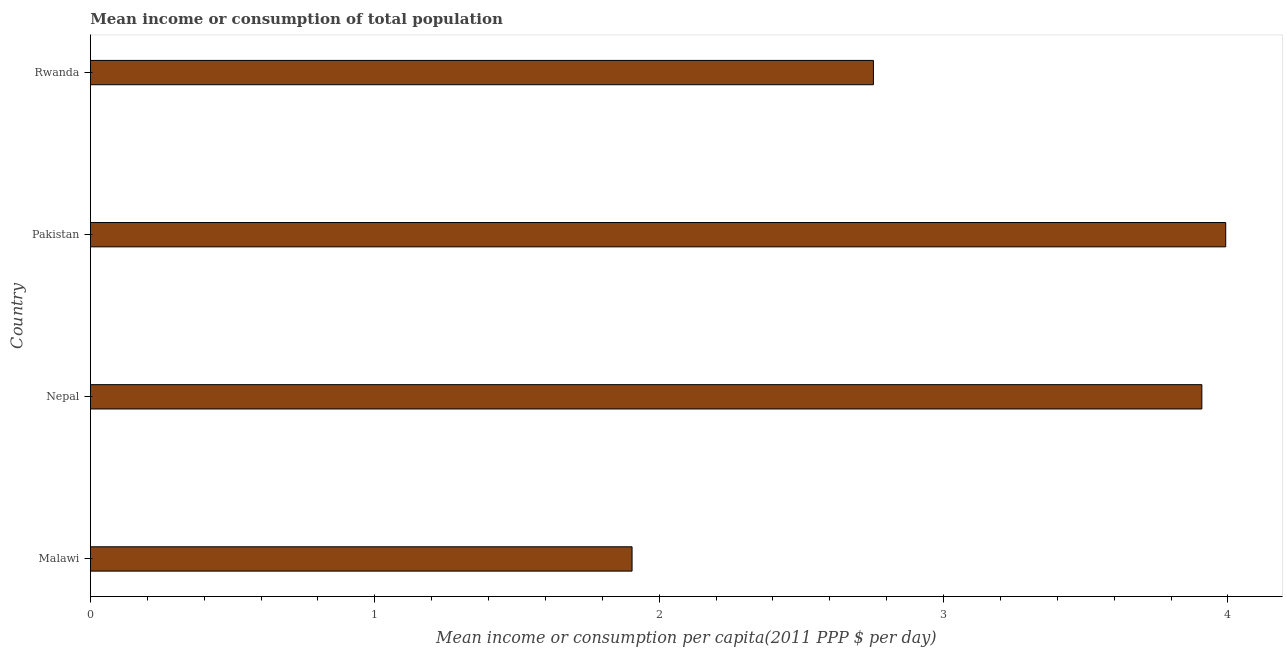Does the graph contain any zero values?
Give a very brief answer. No. What is the title of the graph?
Offer a terse response. Mean income or consumption of total population. What is the label or title of the X-axis?
Ensure brevity in your answer.  Mean income or consumption per capita(2011 PPP $ per day). What is the mean income or consumption in Rwanda?
Offer a very short reply. 2.75. Across all countries, what is the maximum mean income or consumption?
Give a very brief answer. 3.99. Across all countries, what is the minimum mean income or consumption?
Offer a very short reply. 1.9. In which country was the mean income or consumption maximum?
Your answer should be very brief. Pakistan. In which country was the mean income or consumption minimum?
Your answer should be compact. Malawi. What is the sum of the mean income or consumption?
Your response must be concise. 12.56. What is the difference between the mean income or consumption in Malawi and Nepal?
Provide a succinct answer. -2. What is the average mean income or consumption per country?
Offer a terse response. 3.14. What is the median mean income or consumption?
Offer a very short reply. 3.33. What is the ratio of the mean income or consumption in Nepal to that in Rwanda?
Keep it short and to the point. 1.42. What is the difference between the highest and the second highest mean income or consumption?
Provide a short and direct response. 0.08. Is the sum of the mean income or consumption in Nepal and Rwanda greater than the maximum mean income or consumption across all countries?
Your response must be concise. Yes. What is the difference between the highest and the lowest mean income or consumption?
Keep it short and to the point. 2.09. In how many countries, is the mean income or consumption greater than the average mean income or consumption taken over all countries?
Your answer should be compact. 2. Are all the bars in the graph horizontal?
Give a very brief answer. Yes. What is the difference between two consecutive major ticks on the X-axis?
Keep it short and to the point. 1. Are the values on the major ticks of X-axis written in scientific E-notation?
Ensure brevity in your answer.  No. What is the Mean income or consumption per capita(2011 PPP $ per day) in Malawi?
Your response must be concise. 1.9. What is the Mean income or consumption per capita(2011 PPP $ per day) of Nepal?
Provide a short and direct response. 3.91. What is the Mean income or consumption per capita(2011 PPP $ per day) in Pakistan?
Provide a succinct answer. 3.99. What is the Mean income or consumption per capita(2011 PPP $ per day) of Rwanda?
Your answer should be very brief. 2.75. What is the difference between the Mean income or consumption per capita(2011 PPP $ per day) in Malawi and Nepal?
Your response must be concise. -2. What is the difference between the Mean income or consumption per capita(2011 PPP $ per day) in Malawi and Pakistan?
Give a very brief answer. -2.09. What is the difference between the Mean income or consumption per capita(2011 PPP $ per day) in Malawi and Rwanda?
Offer a terse response. -0.85. What is the difference between the Mean income or consumption per capita(2011 PPP $ per day) in Nepal and Pakistan?
Your response must be concise. -0.08. What is the difference between the Mean income or consumption per capita(2011 PPP $ per day) in Nepal and Rwanda?
Make the answer very short. 1.15. What is the difference between the Mean income or consumption per capita(2011 PPP $ per day) in Pakistan and Rwanda?
Offer a terse response. 1.24. What is the ratio of the Mean income or consumption per capita(2011 PPP $ per day) in Malawi to that in Nepal?
Your answer should be compact. 0.49. What is the ratio of the Mean income or consumption per capita(2011 PPP $ per day) in Malawi to that in Pakistan?
Make the answer very short. 0.48. What is the ratio of the Mean income or consumption per capita(2011 PPP $ per day) in Malawi to that in Rwanda?
Offer a terse response. 0.69. What is the ratio of the Mean income or consumption per capita(2011 PPP $ per day) in Nepal to that in Rwanda?
Provide a short and direct response. 1.42. What is the ratio of the Mean income or consumption per capita(2011 PPP $ per day) in Pakistan to that in Rwanda?
Your answer should be compact. 1.45. 